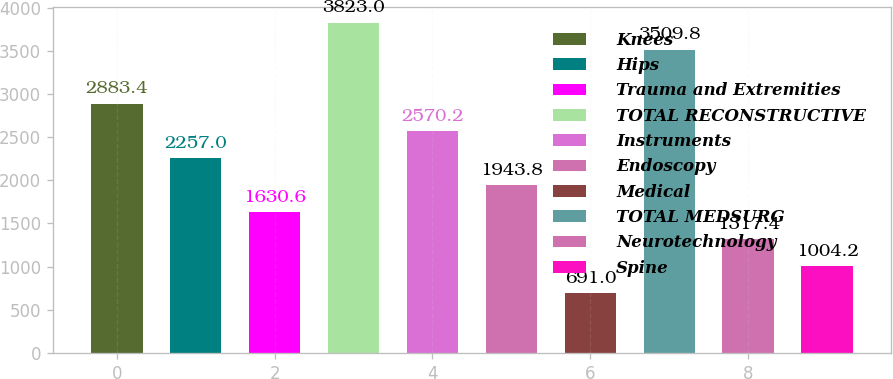<chart> <loc_0><loc_0><loc_500><loc_500><bar_chart><fcel>Knees<fcel>Hips<fcel>Trauma and Extremities<fcel>TOTAL RECONSTRUCTIVE<fcel>Instruments<fcel>Endoscopy<fcel>Medical<fcel>TOTAL MEDSURG<fcel>Neurotechnology<fcel>Spine<nl><fcel>2883.4<fcel>2257<fcel>1630.6<fcel>3823<fcel>2570.2<fcel>1943.8<fcel>691<fcel>3509.8<fcel>1317.4<fcel>1004.2<nl></chart> 